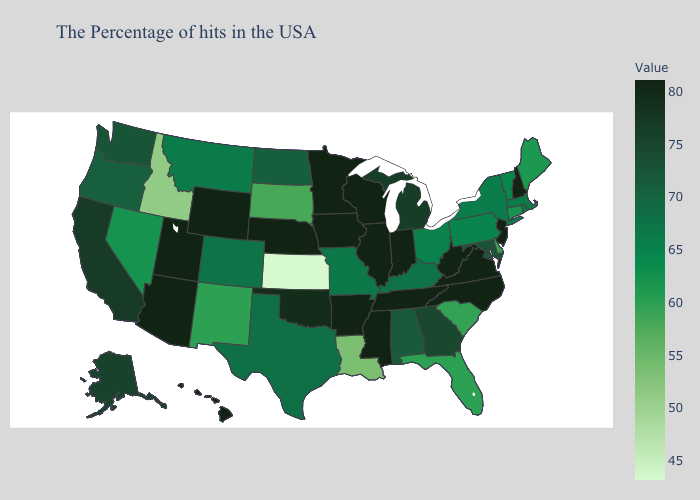Does New York have the lowest value in the Northeast?
Keep it brief. No. Which states have the highest value in the USA?
Short answer required. New Hampshire, New Jersey, Virginia, North Carolina, West Virginia, Indiana, Tennessee, Wisconsin, Illinois, Mississippi, Arkansas, Minnesota, Iowa, Nebraska, Wyoming, Utah, Arizona, Hawaii. Among the states that border Ohio , does Pennsylvania have the highest value?
Quick response, please. No. Which states have the lowest value in the West?
Be succinct. Idaho. Does Montana have the highest value in the USA?
Keep it brief. No. Does the map have missing data?
Write a very short answer. No. Does West Virginia have the highest value in the USA?
Quick response, please. Yes. 